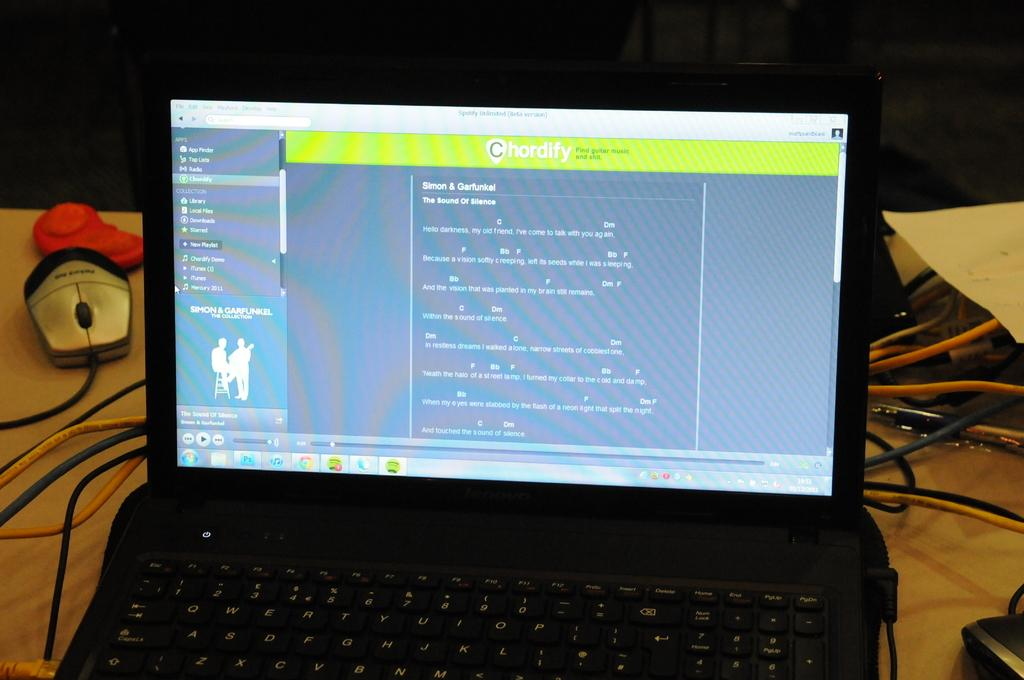<image>
Relay a brief, clear account of the picture shown. A lap top screen that has the word Chordify on it to find guitar music. 